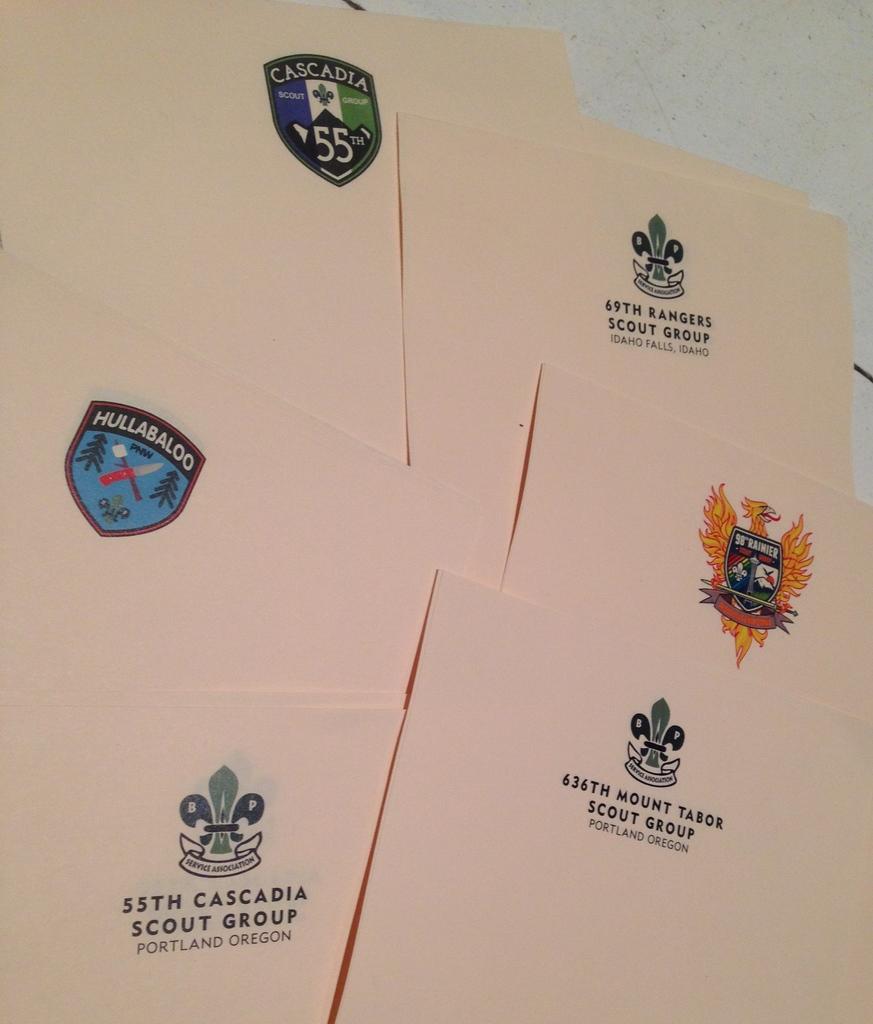What scout group is this from?
Keep it short and to the point. 55th cascadia scout group. Are all these logos scout groups?
Make the answer very short. Yes. 